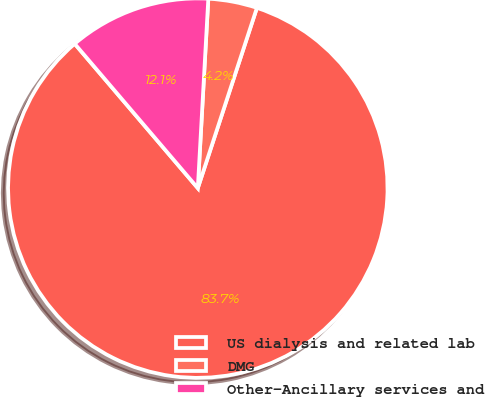<chart> <loc_0><loc_0><loc_500><loc_500><pie_chart><fcel>US dialysis and related lab<fcel>DMG<fcel>Other-Ancillary services and<nl><fcel>83.72%<fcel>4.16%<fcel>12.12%<nl></chart> 